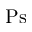<formula> <loc_0><loc_0><loc_500><loc_500>P s</formula> 